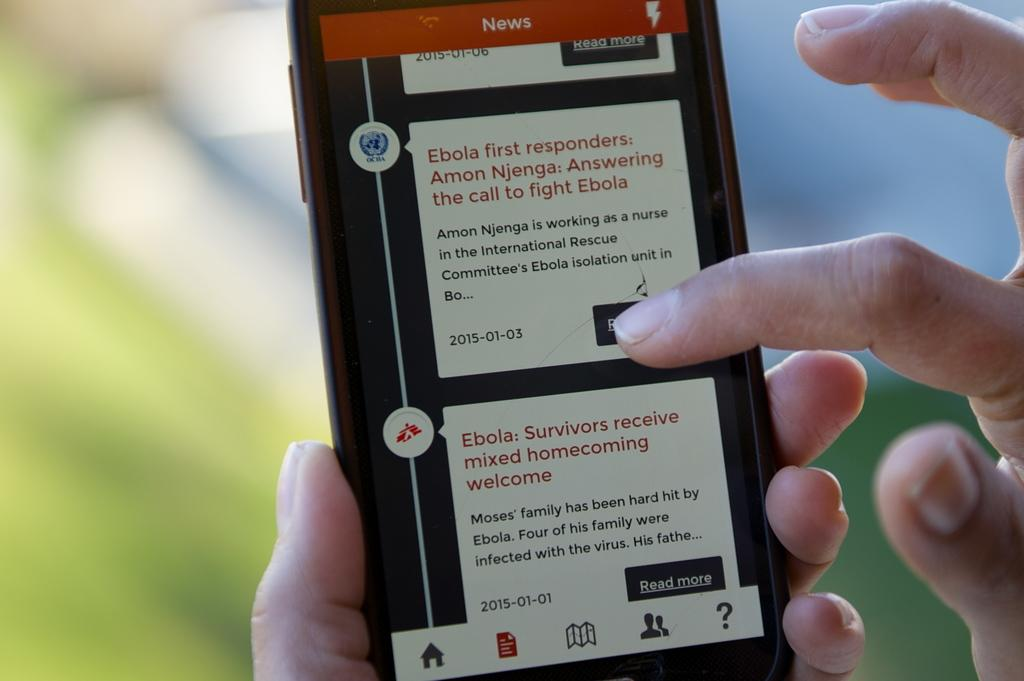Provide a one-sentence caption for the provided image. A hand holding a cell phone with an article about ebola on the screen. 